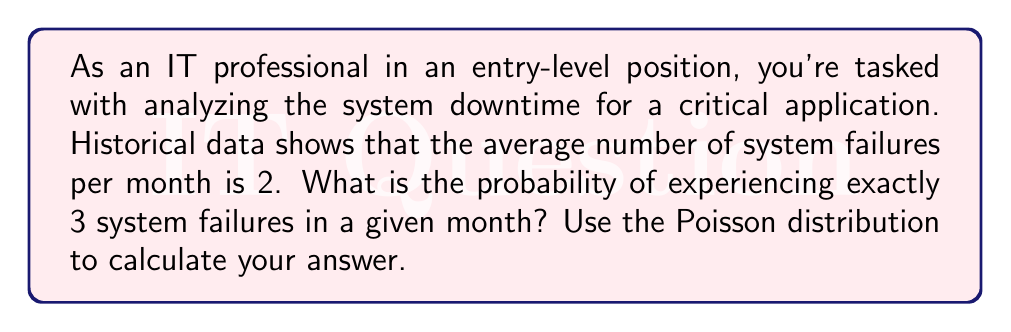What is the answer to this math problem? To solve this problem, we'll use the Poisson distribution, which is ideal for modeling rare events over a fixed interval. In this case, we're looking at system failures over a one-month period.

The Poisson probability mass function is given by:

$$P(X = k) = \frac{e^{-\lambda} \lambda^k}{k!}$$

Where:
- $\lambda$ is the average number of events in the given interval
- $k$ is the number of events we're calculating the probability for
- $e$ is Euler's number (approximately 2.71828)

Given:
- $\lambda = 2$ (average number of system failures per month)
- $k = 3$ (we're calculating the probability of exactly 3 failures)

Let's substitute these values into the formula:

$$P(X = 3) = \frac{e^{-2} 2^3}{3!}$$

Now, let's calculate step-by-step:

1. Calculate $e^{-2}$:
   $e^{-2} \approx 0.1353$

2. Calculate $2^3$:
   $2^3 = 8$

3. Calculate $3!$:
   $3! = 3 \times 2 \times 1 = 6$

4. Put it all together:
   $$P(X = 3) = \frac{0.1353 \times 8}{6} \approx 0.1804$$

5. Convert to a percentage:
   $0.1804 \times 100\% = 18.04\%$

Therefore, the probability of experiencing exactly 3 system failures in a given month is approximately 18.04%.
Answer: 18.04% 